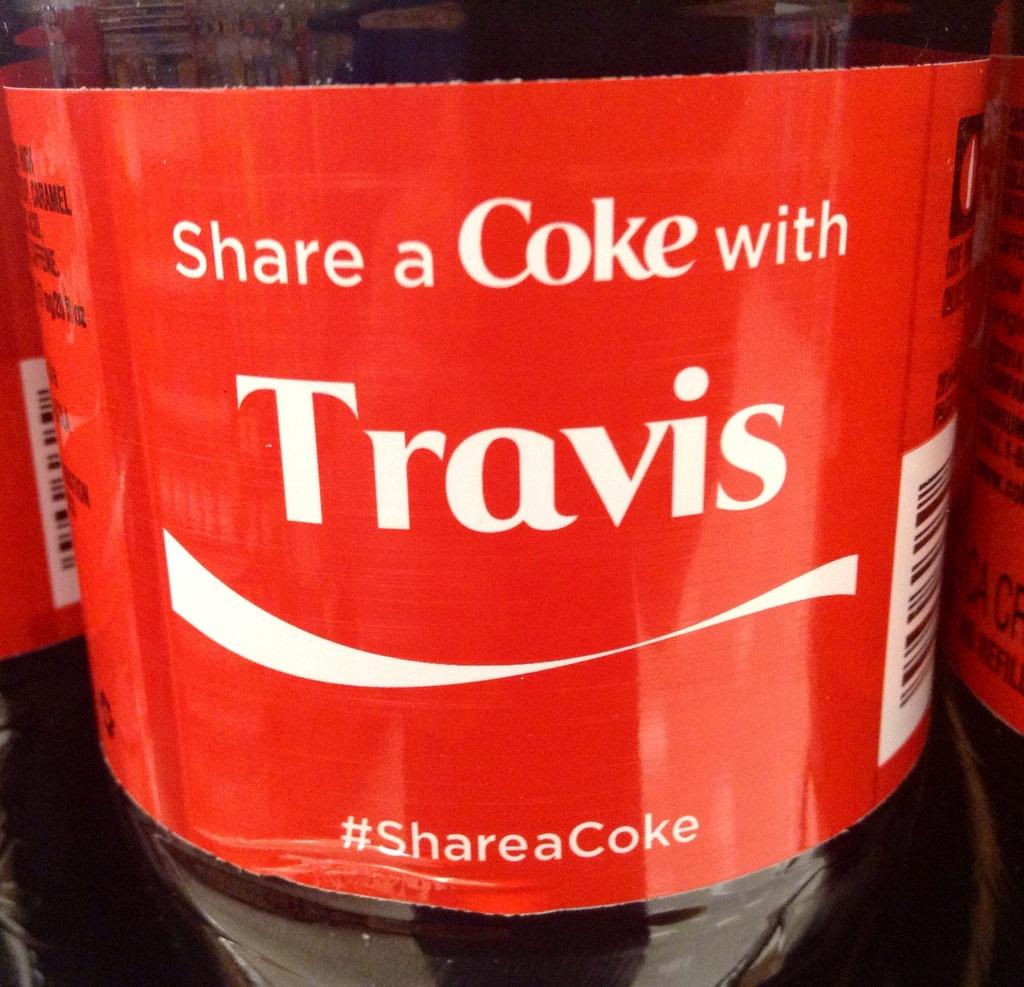Whose name is on that bottle?
Your answer should be very brief. Travis. What should you share with travis?
Ensure brevity in your answer.  Coke. 